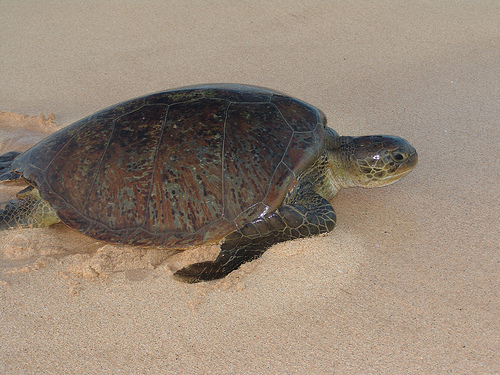<image>
Is the turtle above the sand? No. The turtle is not positioned above the sand. The vertical arrangement shows a different relationship. 